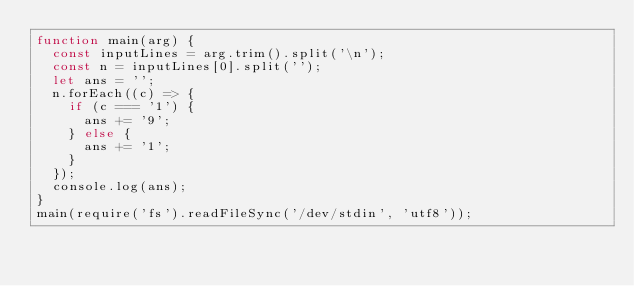Convert code to text. <code><loc_0><loc_0><loc_500><loc_500><_JavaScript_>function main(arg) {
  const inputLines = arg.trim().split('\n');
  const n = inputLines[0].split('');
  let ans = '';
  n.forEach((c) => {
    if (c === '1') {
      ans += '9';
    } else {
      ans += '1';
    }
  });
  console.log(ans);
}
main(require('fs').readFileSync('/dev/stdin', 'utf8'));
</code> 